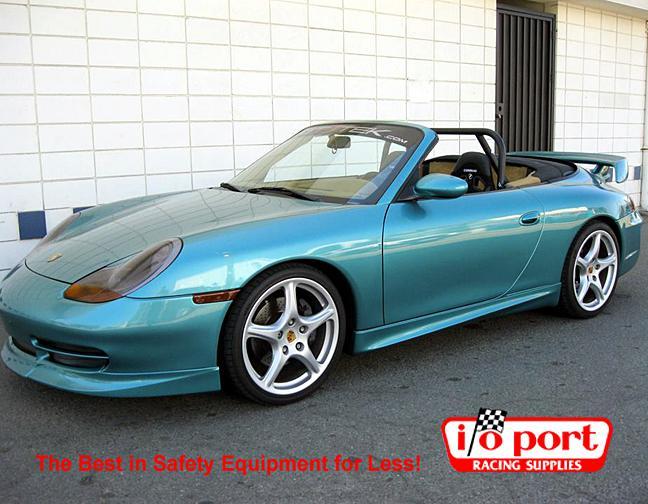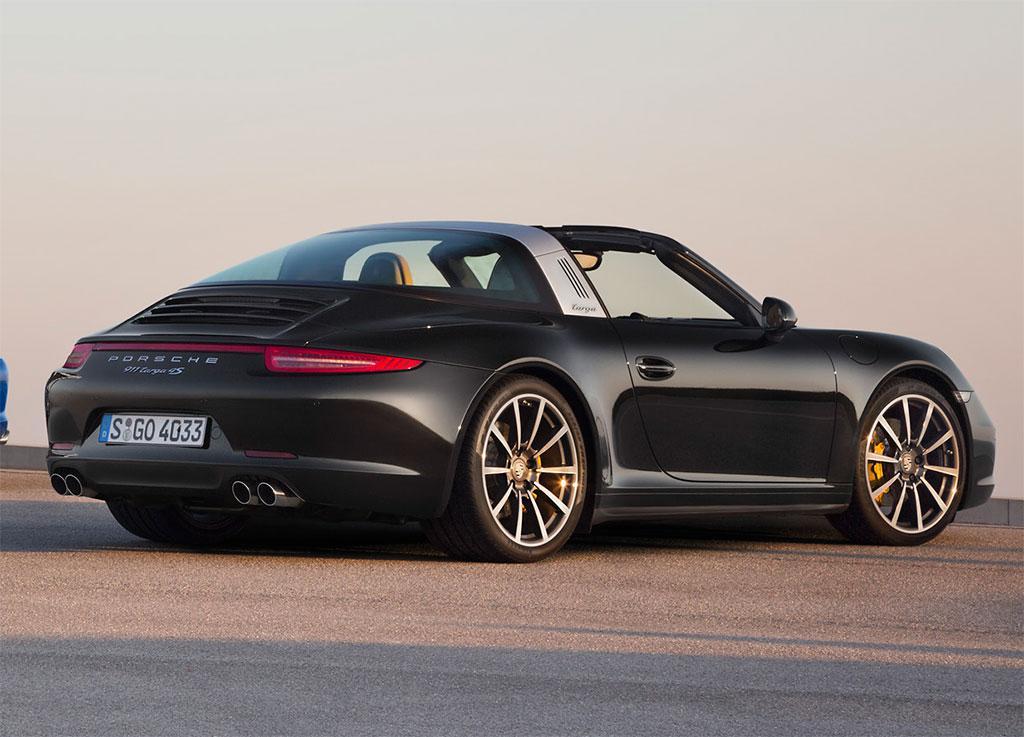The first image is the image on the left, the second image is the image on the right. Considering the images on both sides, is "The roll bars are visible in the image on the right." valid? Answer yes or no. No. 